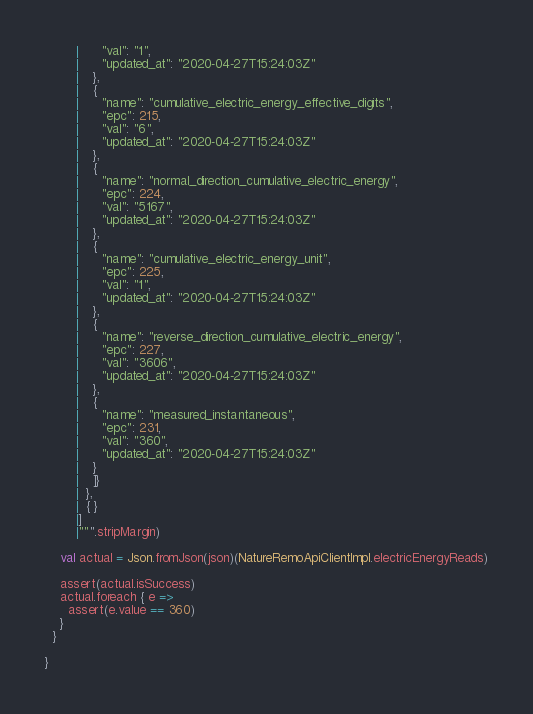<code> <loc_0><loc_0><loc_500><loc_500><_Scala_>        |      "val": "1",
        |      "updated_at": "2020-04-27T15:24:03Z"
        |    },
        |    {
        |      "name": "cumulative_electric_energy_effective_digits",
        |      "epc": 215,
        |      "val": "6",
        |      "updated_at": "2020-04-27T15:24:03Z"
        |    },
        |    {
        |      "name": "normal_direction_cumulative_electric_energy",
        |      "epc": 224,
        |      "val": "5167",
        |      "updated_at": "2020-04-27T15:24:03Z"
        |    },
        |    {
        |      "name": "cumulative_electric_energy_unit",
        |      "epc": 225,
        |      "val": "1",
        |      "updated_at": "2020-04-27T15:24:03Z"
        |    },
        |    {
        |      "name": "reverse_direction_cumulative_electric_energy",
        |      "epc": 227,
        |      "val": "3606",
        |      "updated_at": "2020-04-27T15:24:03Z"
        |    },
        |    {
        |      "name": "measured_instantaneous",
        |      "epc": 231,
        |      "val": "360",
        |      "updated_at": "2020-04-27T15:24:03Z"
        |    }
        |    ]}
        |  },
        |  { }
        |]
        |""".stripMargin)

    val actual = Json.fromJson(json)(NatureRemoApiClientImpl.electricEnergyReads)

    assert(actual.isSuccess)
    actual.foreach { e =>
      assert(e.value == 360)
    }
  }

}
</code> 